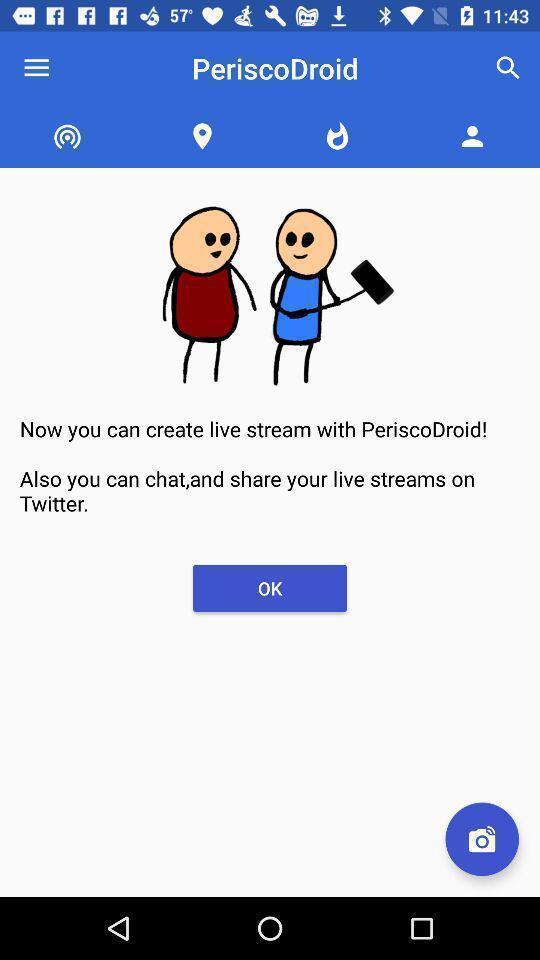Tell me about the visual elements in this screen capture. Page shows to create live chat in chatting app. 